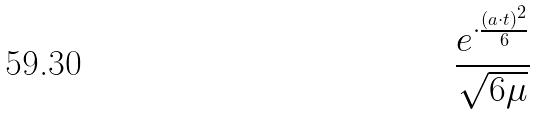<formula> <loc_0><loc_0><loc_500><loc_500>\frac { e ^ { \cdot \frac { ( a \cdot t ) ^ { 2 } } { 6 } } } { \sqrt { 6 \mu } }</formula> 